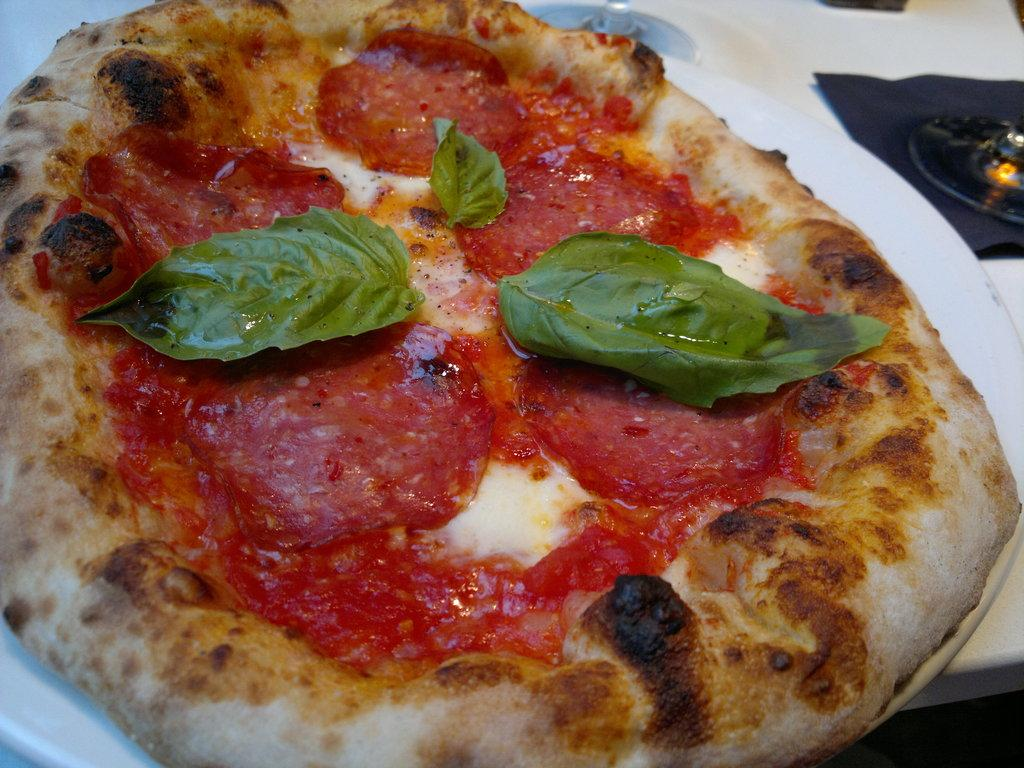What is in the center of the image? There is a table in the center of the image. What is covering the table? There is a cloth on the table. What is on top of the table? There is a plate on the table, and there is a pizza in the plate. What other objects can be seen on the table? There are other objects on the table besides the plate and pizza. How does the pizza increase the profit of the restaurant in the image? There is no information about a restaurant or profit in the image; it only shows a table with a pizza on a plate. What is the expression of surprise on the pizza's face in the image? There is no face or expression of surprise on the pizza in the image; it is a food item and does not have facial features. 